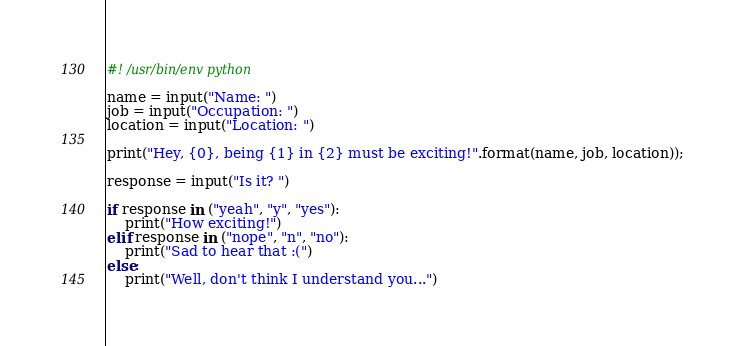Convert code to text. <code><loc_0><loc_0><loc_500><loc_500><_Python_>#! /usr/bin/env python

name = input("Name: ")
job = input("Occupation: ")
location = input("Location: ")

print("Hey, {0}, being {1} in {2} must be exciting!".format(name, job, location));

response = input("Is it? ")

if response in ("yeah", "y", "yes"):
    print("How exciting!")
elif response in ("nope", "n", "no"):
    print("Sad to hear that :(")
else:
    print("Well, don't think I understand you...")
</code> 